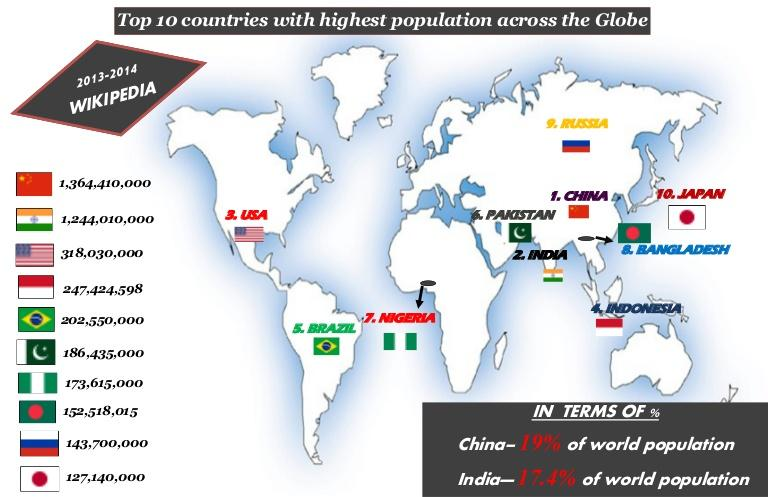Highlight a few significant elements in this photo. According to the infographic, Brazil is the country with the fifth largest population in the world. According to the infographic, Japan has the 10th largest population in the world. There are countries with a population of over a billion, such as China and India. Russia is positioned just below Bangladesh in the list of top 10 countries with the highest population. According to the infographic, Indonesia is the country with the fourth largest population in the world. 